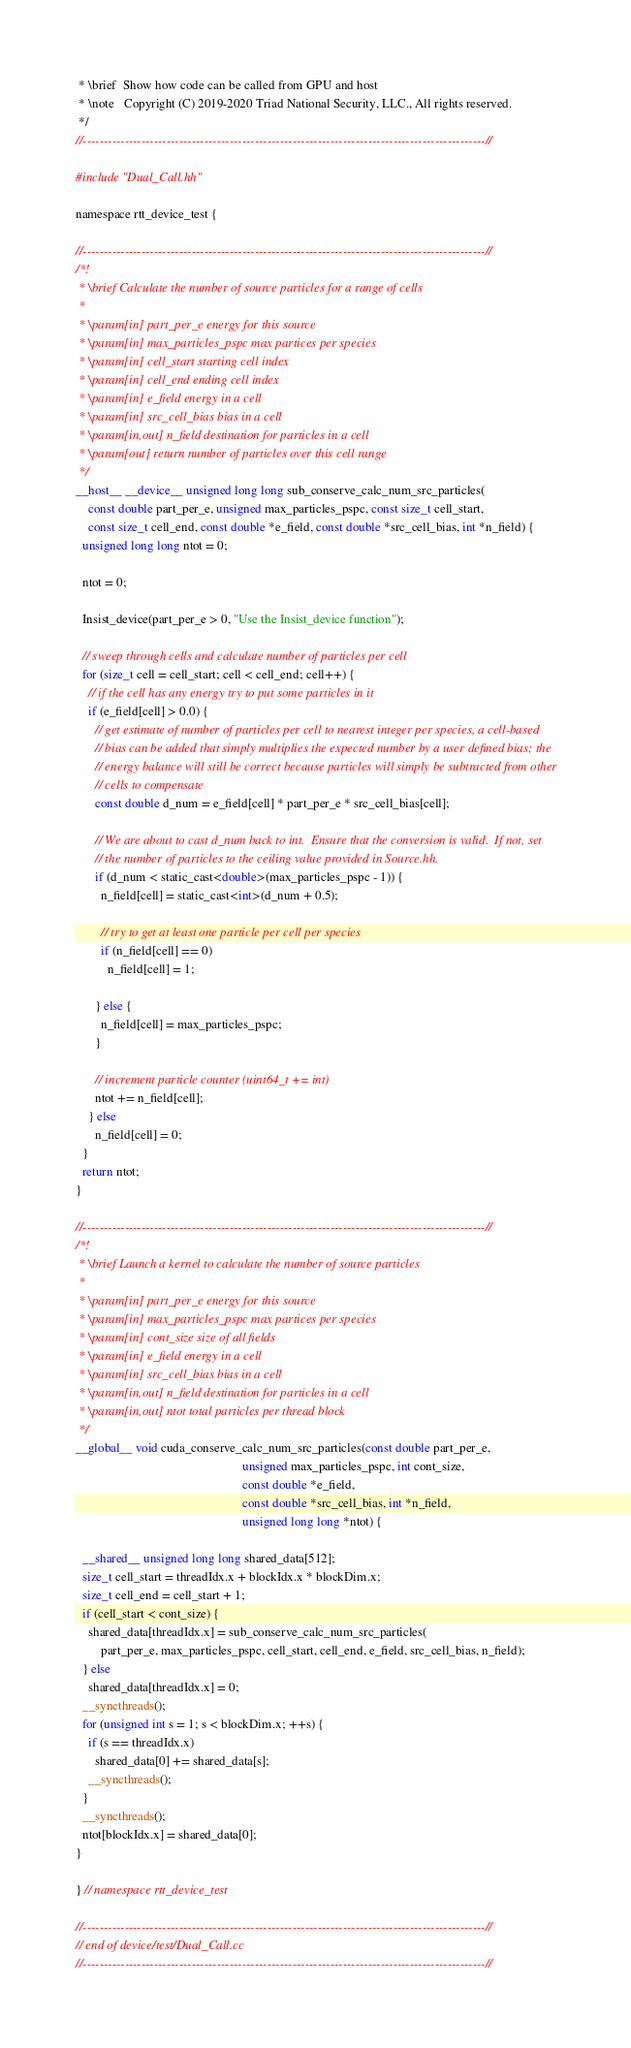<code> <loc_0><loc_0><loc_500><loc_500><_Cuda_> * \brief  Show how code can be called from GPU and host
 * \note   Copyright (C) 2019-2020 Triad National Security, LLC., All rights reserved.
 */
//------------------------------------------------------------------------------------------------//

#include "Dual_Call.hh"

namespace rtt_device_test {

//------------------------------------------------------------------------------------------------//
/*!
 * \brief Calculate the number of source particles for a range of cells
 *
 * \param[in] part_per_e energy for this source
 * \param[in] max_particles_pspc max partices per species
 * \param[in] cell_start starting cell index
 * \param[in] cell_end ending cell index
 * \param[in] e_field energy in a cell
 * \param[in] src_cell_bias bias in a cell
 * \param[in,out] n_field destination for particles in a cell
 * \param[out] return number of particles over this cell range
 */
__host__ __device__ unsigned long long sub_conserve_calc_num_src_particles(
    const double part_per_e, unsigned max_particles_pspc, const size_t cell_start,
    const size_t cell_end, const double *e_field, const double *src_cell_bias, int *n_field) {
  unsigned long long ntot = 0;

  ntot = 0;

  Insist_device(part_per_e > 0, "Use the Insist_device function");

  // sweep through cells and calculate number of particles per cell
  for (size_t cell = cell_start; cell < cell_end; cell++) {
    // if the cell has any energy try to put some particles in it
    if (e_field[cell] > 0.0) {
      // get estimate of number of particles per cell to nearest integer per species, a cell-based
      // bias can be added that simply multiplies the expected number by a user defined bias; the
      // energy balance will still be correct because particles will simply be subtracted from other
      // cells to compensate
      const double d_num = e_field[cell] * part_per_e * src_cell_bias[cell];

      // We are about to cast d_num back to int.  Ensure that the conversion is valid.  If not, set
      // the number of particles to the ceiling value provided in Source.hh.
      if (d_num < static_cast<double>(max_particles_pspc - 1)) {
        n_field[cell] = static_cast<int>(d_num + 0.5);

        // try to get at least one particle per cell per species
        if (n_field[cell] == 0)
          n_field[cell] = 1;

      } else {
        n_field[cell] = max_particles_pspc;
      }

      // increment particle counter (uint64_t += int)
      ntot += n_field[cell];
    } else
      n_field[cell] = 0;
  }
  return ntot;
}

//------------------------------------------------------------------------------------------------//
/*!
 * \brief Launch a kernel to calculate the number of source particles
 *
 * \param[in] part_per_e energy for this source
 * \param[in] max_particles_pspc max partices per species
 * \param[in] cont_size size of all fields
 * \param[in] e_field energy in a cell
 * \param[in] src_cell_bias bias in a cell
 * \param[in,out] n_field destination for particles in a cell
 * \param[in,out] ntot total particles per thread block
 */
__global__ void cuda_conserve_calc_num_src_particles(const double part_per_e,
                                                     unsigned max_particles_pspc, int cont_size,
                                                     const double *e_field,
                                                     const double *src_cell_bias, int *n_field,
                                                     unsigned long long *ntot) {

  __shared__ unsigned long long shared_data[512];
  size_t cell_start = threadIdx.x + blockIdx.x * blockDim.x;
  size_t cell_end = cell_start + 1;
  if (cell_start < cont_size) {
    shared_data[threadIdx.x] = sub_conserve_calc_num_src_particles(
        part_per_e, max_particles_pspc, cell_start, cell_end, e_field, src_cell_bias, n_field);
  } else
    shared_data[threadIdx.x] = 0;
  __syncthreads();
  for (unsigned int s = 1; s < blockDim.x; ++s) {
    if (s == threadIdx.x)
      shared_data[0] += shared_data[s];
    __syncthreads();
  }
  __syncthreads();
  ntot[blockIdx.x] = shared_data[0];
}

} // namespace rtt_device_test

//------------------------------------------------------------------------------------------------//
// end of device/test/Dual_Call.cc
//------------------------------------------------------------------------------------------------//
</code> 